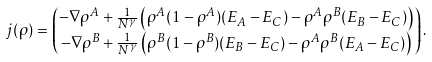<formula> <loc_0><loc_0><loc_500><loc_500>j ( \rho ) & = \begin{pmatrix} - \nabla \rho ^ { A } + \frac { 1 } { N ^ { \gamma } } \left ( \rho ^ { A } ( 1 - \rho ^ { A } ) ( E _ { A } - E _ { C } ) - \rho ^ { A } \rho ^ { B } ( E _ { B } - E _ { C } ) \right ) \\ - \nabla \rho ^ { B } + \frac { 1 } { N ^ { \gamma } } \left ( \rho ^ { B } ( 1 - \rho ^ { B } ) ( E _ { B } - E _ { C } ) - \rho ^ { A } \rho ^ { B } ( E _ { A } - E _ { C } ) \right ) \end{pmatrix} .</formula> 